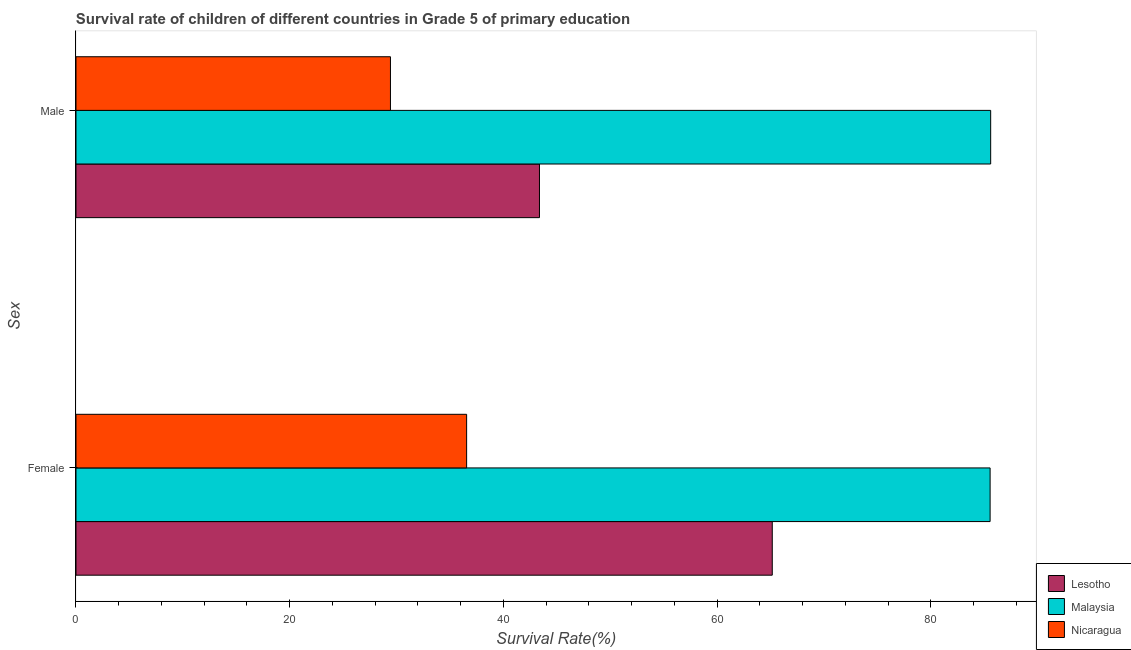How many groups of bars are there?
Offer a very short reply. 2. Are the number of bars per tick equal to the number of legend labels?
Keep it short and to the point. Yes. How many bars are there on the 2nd tick from the top?
Your answer should be compact. 3. What is the label of the 2nd group of bars from the top?
Give a very brief answer. Female. What is the survival rate of male students in primary education in Lesotho?
Provide a succinct answer. 43.37. Across all countries, what is the maximum survival rate of male students in primary education?
Your response must be concise. 85.6. Across all countries, what is the minimum survival rate of male students in primary education?
Make the answer very short. 29.43. In which country was the survival rate of male students in primary education maximum?
Give a very brief answer. Malaysia. In which country was the survival rate of male students in primary education minimum?
Provide a succinct answer. Nicaragua. What is the total survival rate of female students in primary education in the graph?
Your answer should be very brief. 187.26. What is the difference between the survival rate of female students in primary education in Malaysia and that in Lesotho?
Your response must be concise. 20.39. What is the difference between the survival rate of female students in primary education in Malaysia and the survival rate of male students in primary education in Nicaragua?
Your response must be concise. 56.12. What is the average survival rate of male students in primary education per country?
Keep it short and to the point. 52.8. What is the difference between the survival rate of female students in primary education and survival rate of male students in primary education in Nicaragua?
Your answer should be compact. 7.13. What is the ratio of the survival rate of female students in primary education in Malaysia to that in Lesotho?
Provide a succinct answer. 1.31. What does the 1st bar from the top in Male represents?
Give a very brief answer. Nicaragua. What does the 3rd bar from the bottom in Male represents?
Make the answer very short. Nicaragua. How many bars are there?
Make the answer very short. 6. Are all the bars in the graph horizontal?
Your answer should be compact. Yes. How many countries are there in the graph?
Provide a short and direct response. 3. What is the difference between two consecutive major ticks on the X-axis?
Provide a succinct answer. 20. Does the graph contain grids?
Make the answer very short. No. Where does the legend appear in the graph?
Ensure brevity in your answer.  Bottom right. How many legend labels are there?
Give a very brief answer. 3. What is the title of the graph?
Make the answer very short. Survival rate of children of different countries in Grade 5 of primary education. What is the label or title of the X-axis?
Offer a very short reply. Survival Rate(%). What is the label or title of the Y-axis?
Your answer should be very brief. Sex. What is the Survival Rate(%) in Lesotho in Female?
Your response must be concise. 65.16. What is the Survival Rate(%) in Malaysia in Female?
Your answer should be compact. 85.54. What is the Survival Rate(%) in Nicaragua in Female?
Keep it short and to the point. 36.56. What is the Survival Rate(%) of Lesotho in Male?
Make the answer very short. 43.37. What is the Survival Rate(%) in Malaysia in Male?
Make the answer very short. 85.6. What is the Survival Rate(%) in Nicaragua in Male?
Your answer should be very brief. 29.43. Across all Sex, what is the maximum Survival Rate(%) in Lesotho?
Provide a succinct answer. 65.16. Across all Sex, what is the maximum Survival Rate(%) in Malaysia?
Offer a very short reply. 85.6. Across all Sex, what is the maximum Survival Rate(%) of Nicaragua?
Make the answer very short. 36.56. Across all Sex, what is the minimum Survival Rate(%) in Lesotho?
Provide a succinct answer. 43.37. Across all Sex, what is the minimum Survival Rate(%) in Malaysia?
Provide a short and direct response. 85.54. Across all Sex, what is the minimum Survival Rate(%) of Nicaragua?
Keep it short and to the point. 29.43. What is the total Survival Rate(%) of Lesotho in the graph?
Provide a succinct answer. 108.53. What is the total Survival Rate(%) of Malaysia in the graph?
Provide a short and direct response. 171.14. What is the total Survival Rate(%) of Nicaragua in the graph?
Your answer should be compact. 65.98. What is the difference between the Survival Rate(%) in Lesotho in Female and that in Male?
Ensure brevity in your answer.  21.79. What is the difference between the Survival Rate(%) of Malaysia in Female and that in Male?
Provide a succinct answer. -0.05. What is the difference between the Survival Rate(%) in Nicaragua in Female and that in Male?
Provide a succinct answer. 7.13. What is the difference between the Survival Rate(%) of Lesotho in Female and the Survival Rate(%) of Malaysia in Male?
Provide a succinct answer. -20.44. What is the difference between the Survival Rate(%) in Lesotho in Female and the Survival Rate(%) in Nicaragua in Male?
Your response must be concise. 35.73. What is the difference between the Survival Rate(%) in Malaysia in Female and the Survival Rate(%) in Nicaragua in Male?
Provide a succinct answer. 56.12. What is the average Survival Rate(%) of Lesotho per Sex?
Your response must be concise. 54.27. What is the average Survival Rate(%) of Malaysia per Sex?
Make the answer very short. 85.57. What is the average Survival Rate(%) in Nicaragua per Sex?
Ensure brevity in your answer.  32.99. What is the difference between the Survival Rate(%) of Lesotho and Survival Rate(%) of Malaysia in Female?
Make the answer very short. -20.39. What is the difference between the Survival Rate(%) of Lesotho and Survival Rate(%) of Nicaragua in Female?
Offer a very short reply. 28.6. What is the difference between the Survival Rate(%) in Malaysia and Survival Rate(%) in Nicaragua in Female?
Your answer should be very brief. 48.99. What is the difference between the Survival Rate(%) in Lesotho and Survival Rate(%) in Malaysia in Male?
Provide a short and direct response. -42.23. What is the difference between the Survival Rate(%) in Lesotho and Survival Rate(%) in Nicaragua in Male?
Your response must be concise. 13.94. What is the difference between the Survival Rate(%) of Malaysia and Survival Rate(%) of Nicaragua in Male?
Make the answer very short. 56.17. What is the ratio of the Survival Rate(%) in Lesotho in Female to that in Male?
Your response must be concise. 1.5. What is the ratio of the Survival Rate(%) of Malaysia in Female to that in Male?
Offer a terse response. 1. What is the ratio of the Survival Rate(%) of Nicaragua in Female to that in Male?
Make the answer very short. 1.24. What is the difference between the highest and the second highest Survival Rate(%) in Lesotho?
Ensure brevity in your answer.  21.79. What is the difference between the highest and the second highest Survival Rate(%) of Malaysia?
Offer a terse response. 0.05. What is the difference between the highest and the second highest Survival Rate(%) in Nicaragua?
Your answer should be very brief. 7.13. What is the difference between the highest and the lowest Survival Rate(%) in Lesotho?
Your answer should be compact. 21.79. What is the difference between the highest and the lowest Survival Rate(%) of Malaysia?
Offer a terse response. 0.05. What is the difference between the highest and the lowest Survival Rate(%) of Nicaragua?
Make the answer very short. 7.13. 